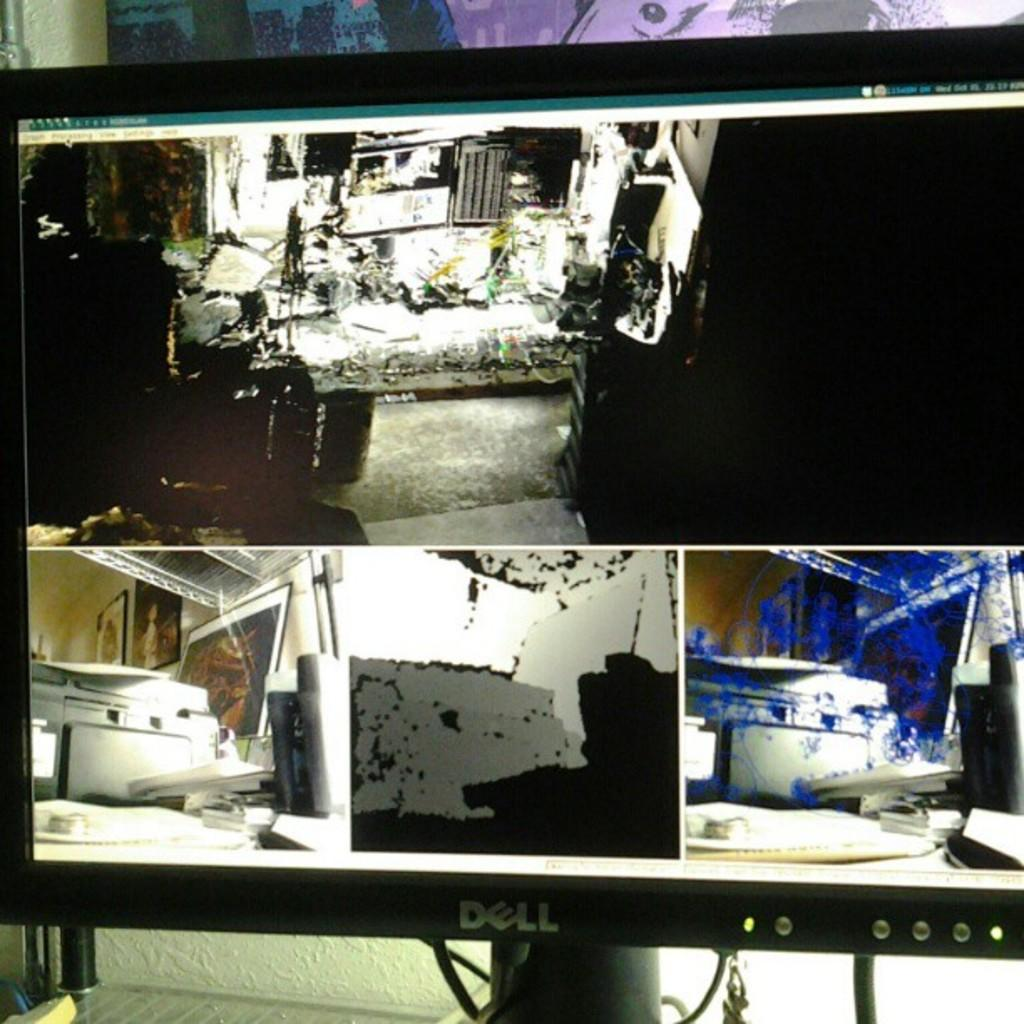<image>
Relay a brief, clear account of the picture shown. The monitor is a dell and displays some rooms 